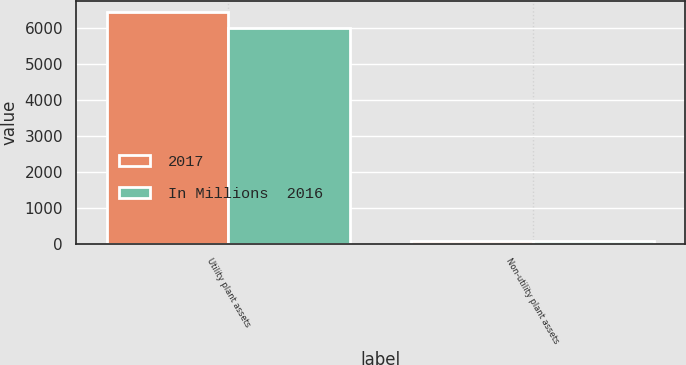Convert chart. <chart><loc_0><loc_0><loc_500><loc_500><stacked_bar_chart><ecel><fcel>Utility plant assets<fcel>Non-utility plant assets<nl><fcel>2017<fcel>6439<fcel>71<nl><fcel>In Millions  2016<fcel>5993<fcel>63<nl></chart> 